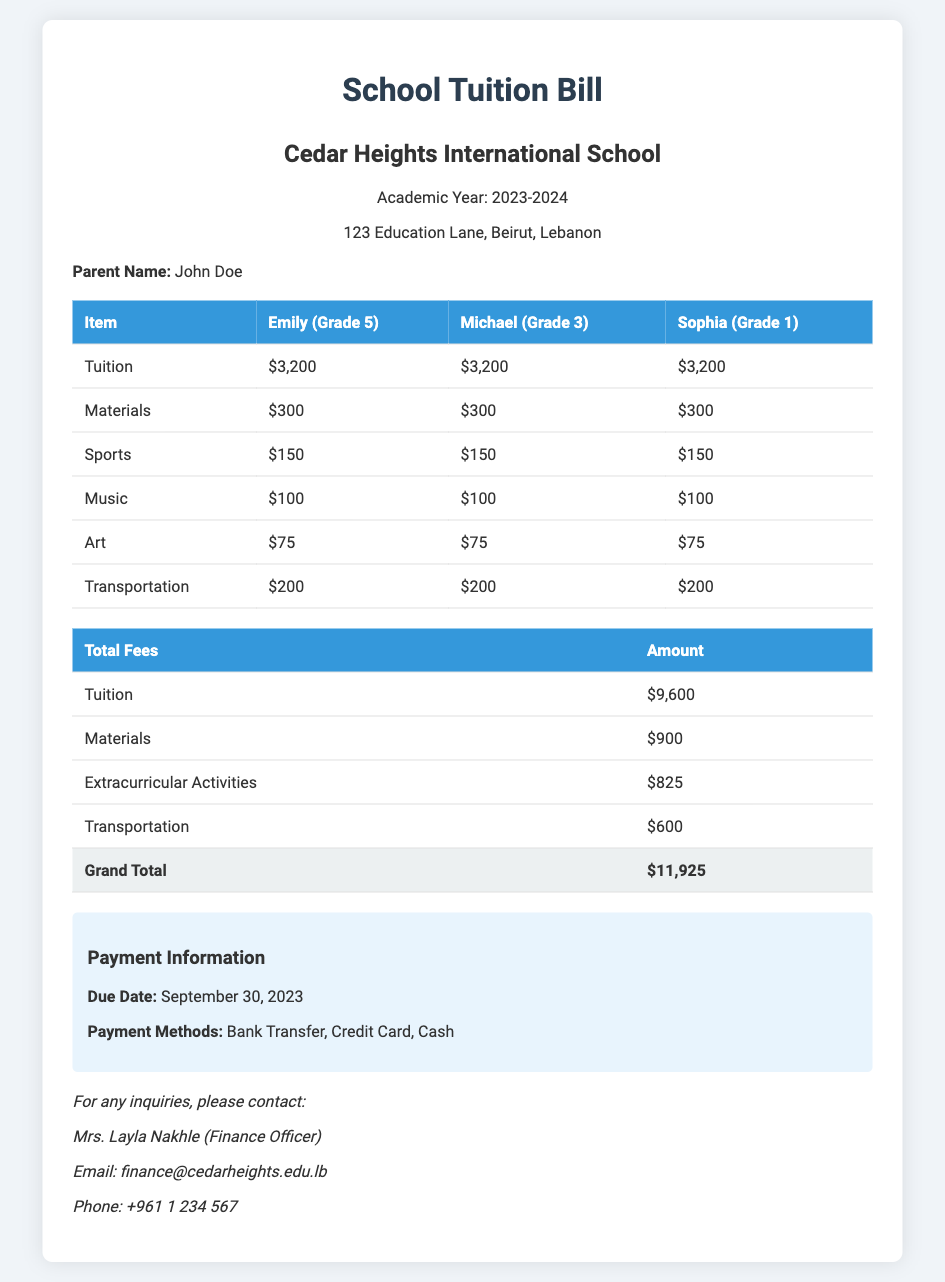What is the name of the school? The name of the school is mentioned in the document as Cedar Heights International School.
Answer: Cedar Heights International School What is the total amount for Emily's tuition? The total amount for Emily's tuition is listed in the document as $3,200.
Answer: $3,200 What is the grand total amount due? The grand total amount due is calculated from all fees listed and presented as $11,925.
Answer: $11,925 When is the payment due date? The due date for payment is explicitly stated in the document as September 30, 2023.
Answer: September 30, 2023 Who should be contacted for inquiries? The document specifies that inquiries should be directed to Mrs. Layla Nakhle.
Answer: Mrs. Layla Nakhle What is the total fee for extracurricular activities? The total fee for extracurricular activities, which includes sports, music, and art fees, is noted as $825.
Answer: $825 How much is the transportation fee for each child? The transportation fee for each child is provided in the document as $200.
Answer: $200 What payment methods are accepted? The accepted payment methods are outlined in the document as Bank Transfer, Credit Card, and Cash.
Answer: Bank Transfer, Credit Card, Cash 